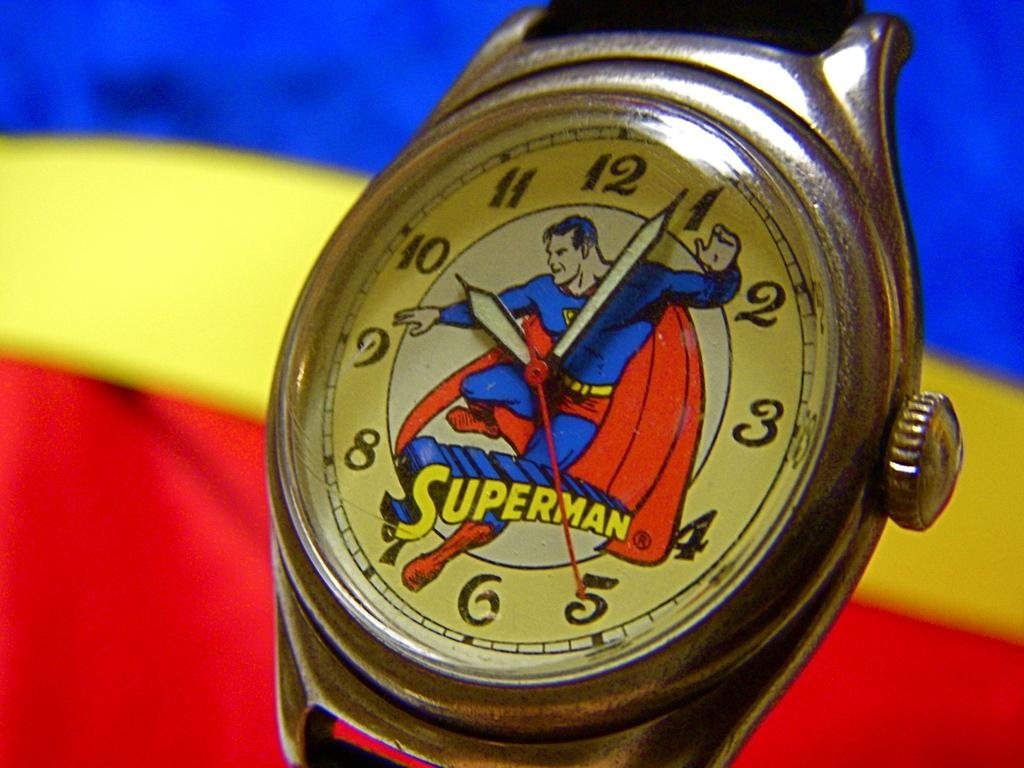<image>
Write a terse but informative summary of the picture. An antique watch that says Superman with an image of Superman on the watch face 